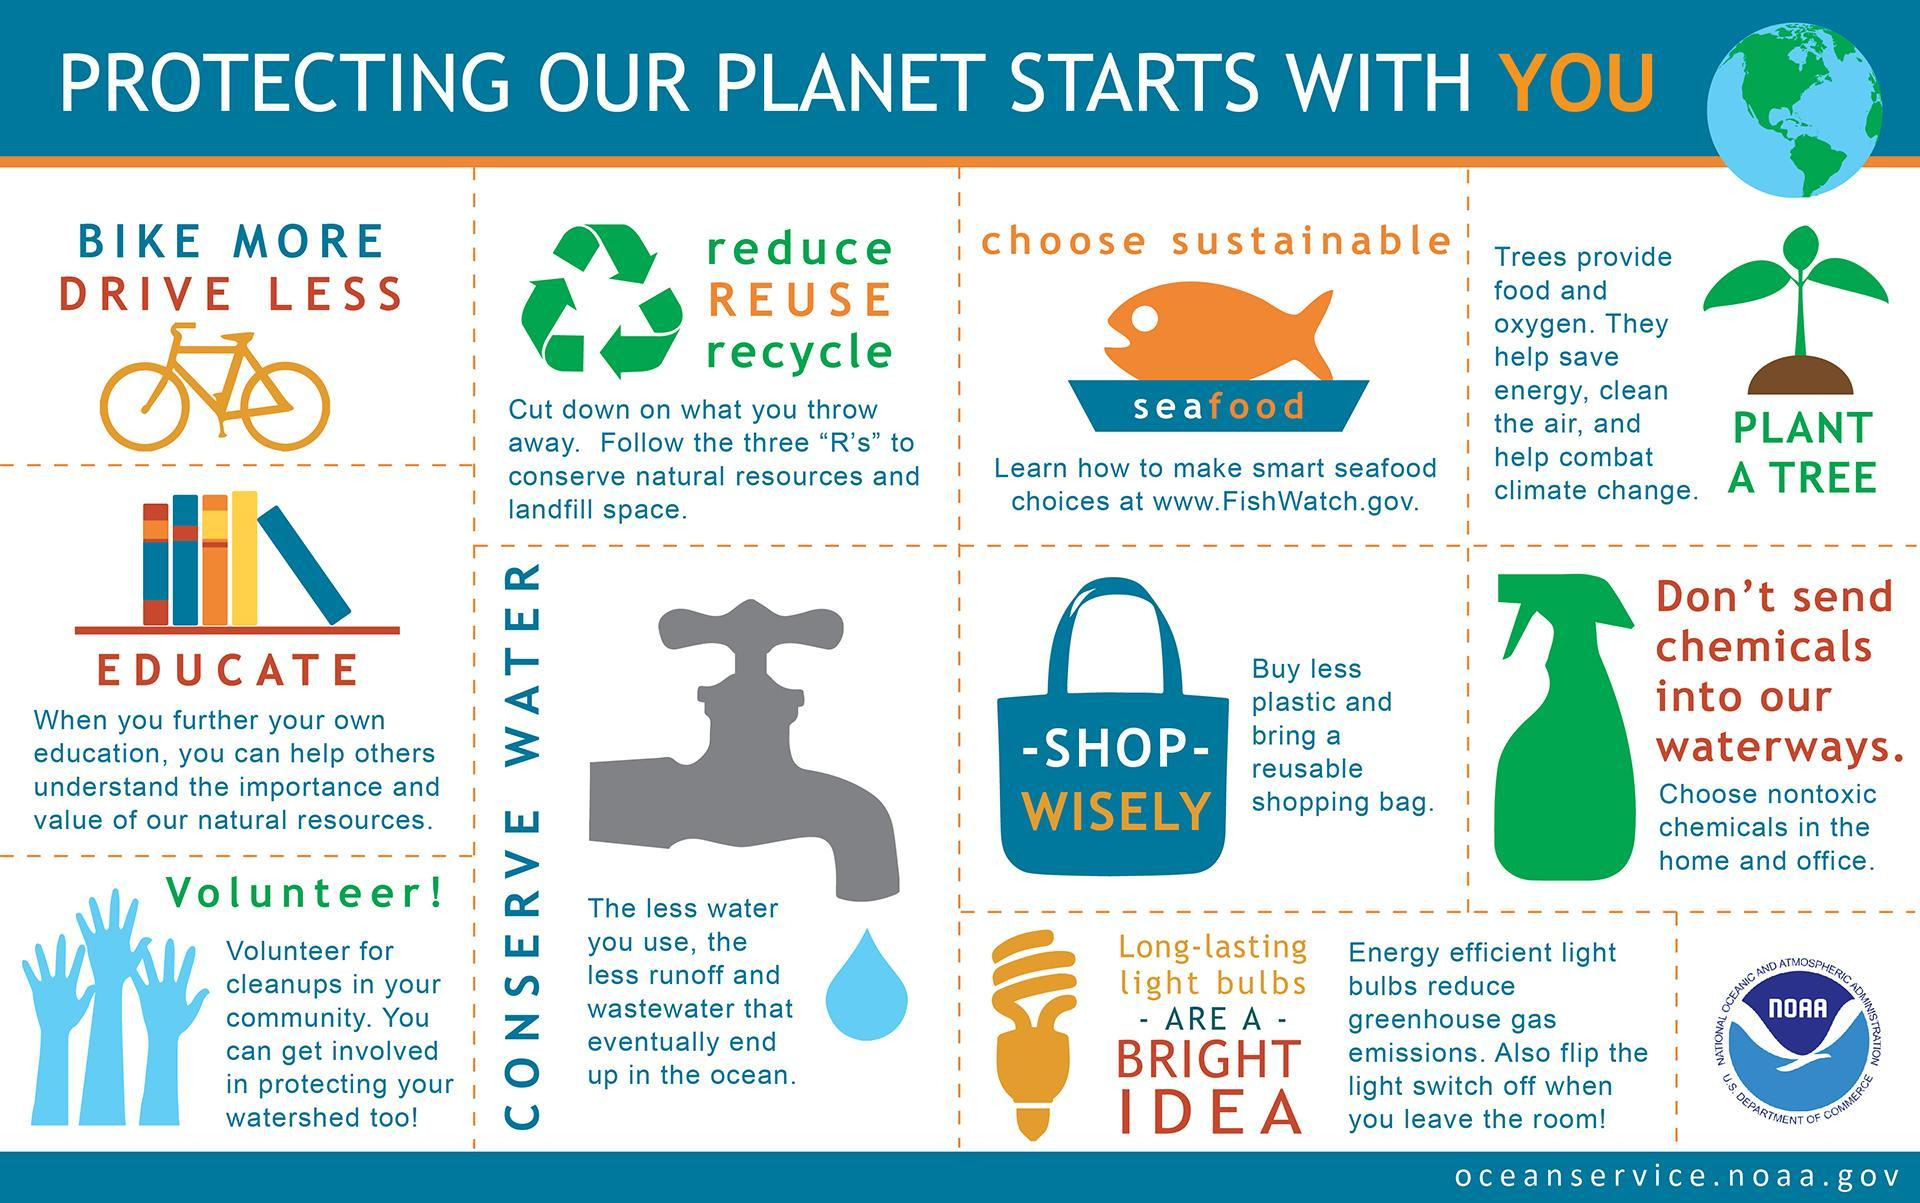Which mode of transportation does not leave any carbon foot prints, car, bus, train, cycle, or plane? or
Answer the question with a short phrase. cycle Which eatable is considered to be environment friendly? seafood What are the steps to be followed in order to stop destruction of natural resources? reduce, REUSE, recycle 